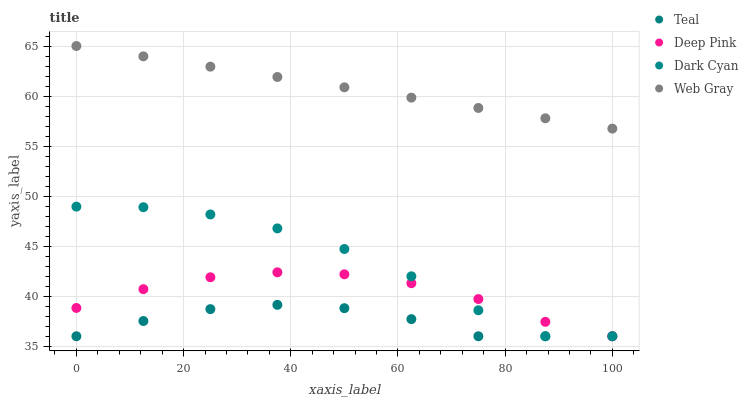Does Teal have the minimum area under the curve?
Answer yes or no. Yes. Does Web Gray have the maximum area under the curve?
Answer yes or no. Yes. Does Deep Pink have the minimum area under the curve?
Answer yes or no. No. Does Deep Pink have the maximum area under the curve?
Answer yes or no. No. Is Web Gray the smoothest?
Answer yes or no. Yes. Is Dark Cyan the roughest?
Answer yes or no. Yes. Is Deep Pink the smoothest?
Answer yes or no. No. Is Deep Pink the roughest?
Answer yes or no. No. Does Dark Cyan have the lowest value?
Answer yes or no. Yes. Does Web Gray have the lowest value?
Answer yes or no. No. Does Web Gray have the highest value?
Answer yes or no. Yes. Does Deep Pink have the highest value?
Answer yes or no. No. Is Teal less than Web Gray?
Answer yes or no. Yes. Is Web Gray greater than Dark Cyan?
Answer yes or no. Yes. Does Teal intersect Dark Cyan?
Answer yes or no. Yes. Is Teal less than Dark Cyan?
Answer yes or no. No. Is Teal greater than Dark Cyan?
Answer yes or no. No. Does Teal intersect Web Gray?
Answer yes or no. No. 